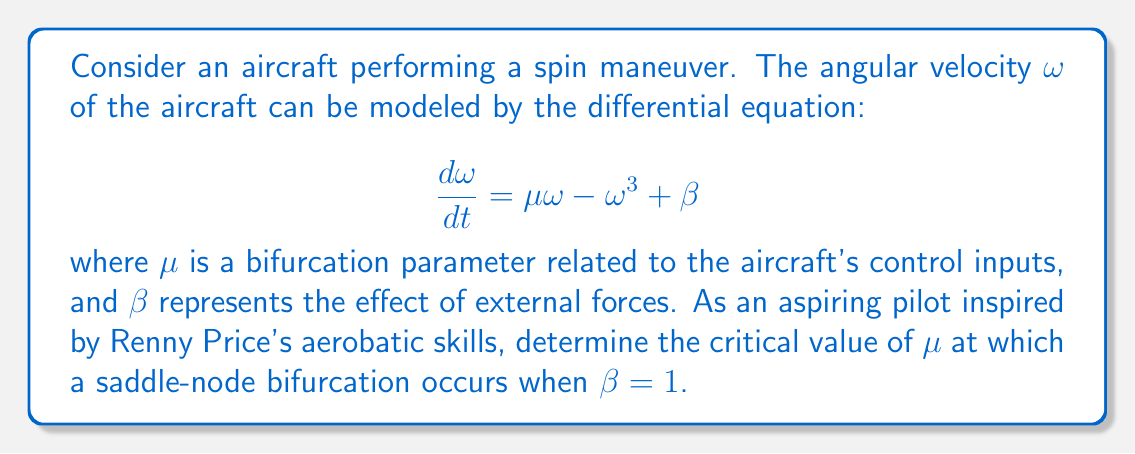Give your solution to this math problem. To solve this problem, we'll follow these steps:

1) In a saddle-node bifurcation, the system transitions from having no equilibrium points to having two equilibrium points (or vice versa). This occurs when the system has exactly one equilibrium point.

2) To find the equilibrium points, we set $\frac{d\omega}{dt} = 0$:

   $$0 = \mu\omega - \omega^3 + \beta$$

3) Rearranging the equation:

   $$\omega^3 - \mu\omega - \beta = 0$$

4) For a saddle-node bifurcation, this equation should have exactly one solution. This occurs when the equation has a double root, which happens when its discriminant is zero.

5) The discriminant of a cubic equation $ax^3 + bx^2 + cx + d = 0$ is given by:

   $$\Delta = 18abcd - 4b^3d + b^2c^2 - 4ac^3 - 27a^2d^2$$

6) In our case, $a=1$, $b=0$, $c=-\mu$, and $d=-\beta$. Substituting these into the discriminant formula:

   $$\Delta = 4\mu^3 + 27\beta^2$$

7) Setting this equal to zero:

   $$4\mu^3 + 27\beta^2 = 0$$

8) We're given that $\beta = 1$, so:

   $$4\mu^3 + 27 = 0$$

9) Solving for $\mu$:

   $$\mu^3 = -\frac{27}{4}$$
   $$\mu = -\sqrt[3]{\frac{27}{4}}$$

10) The critical value is the positive root, so we take the negative of this:

    $$\mu_{critical} = \sqrt[3]{\frac{27}{4}}$$

This is the value of $\mu$ at which the saddle-node bifurcation occurs.
Answer: $\sqrt[3]{\frac{27}{4}}$ 